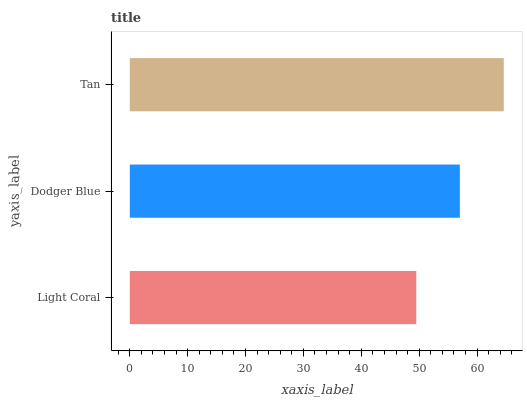Is Light Coral the minimum?
Answer yes or no. Yes. Is Tan the maximum?
Answer yes or no. Yes. Is Dodger Blue the minimum?
Answer yes or no. No. Is Dodger Blue the maximum?
Answer yes or no. No. Is Dodger Blue greater than Light Coral?
Answer yes or no. Yes. Is Light Coral less than Dodger Blue?
Answer yes or no. Yes. Is Light Coral greater than Dodger Blue?
Answer yes or no. No. Is Dodger Blue less than Light Coral?
Answer yes or no. No. Is Dodger Blue the high median?
Answer yes or no. Yes. Is Dodger Blue the low median?
Answer yes or no. Yes. Is Tan the high median?
Answer yes or no. No. Is Tan the low median?
Answer yes or no. No. 